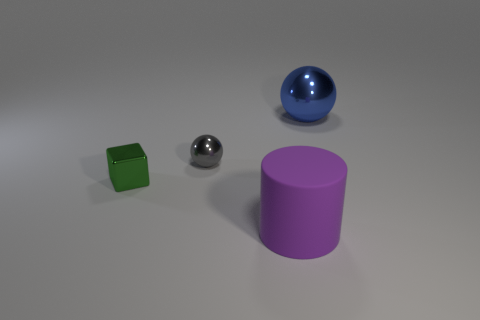Is there anything else that is made of the same material as the large purple thing?
Ensure brevity in your answer.  No. Is the shape of the big blue metallic thing the same as the gray thing?
Offer a terse response. Yes. There is another metal thing that is the same shape as the large metal thing; what color is it?
Make the answer very short. Gray. How many objects are either large objects that are left of the large blue shiny sphere or big cylinders?
Provide a short and direct response. 1. There is a ball that is to the right of the big purple rubber thing; what is its size?
Offer a terse response. Large. Is the number of gray spheres less than the number of yellow rubber blocks?
Your response must be concise. No. Is the sphere that is in front of the big blue metallic ball made of the same material as the big object behind the tiny block?
Provide a succinct answer. Yes. What shape is the gray object that is to the left of the shiny object that is behind the tiny metal thing that is behind the tiny green metallic thing?
Give a very brief answer. Sphere. What number of purple cylinders have the same material as the tiny sphere?
Make the answer very short. 0. What number of spheres are to the left of the big object behind the big purple matte thing?
Give a very brief answer. 1. 